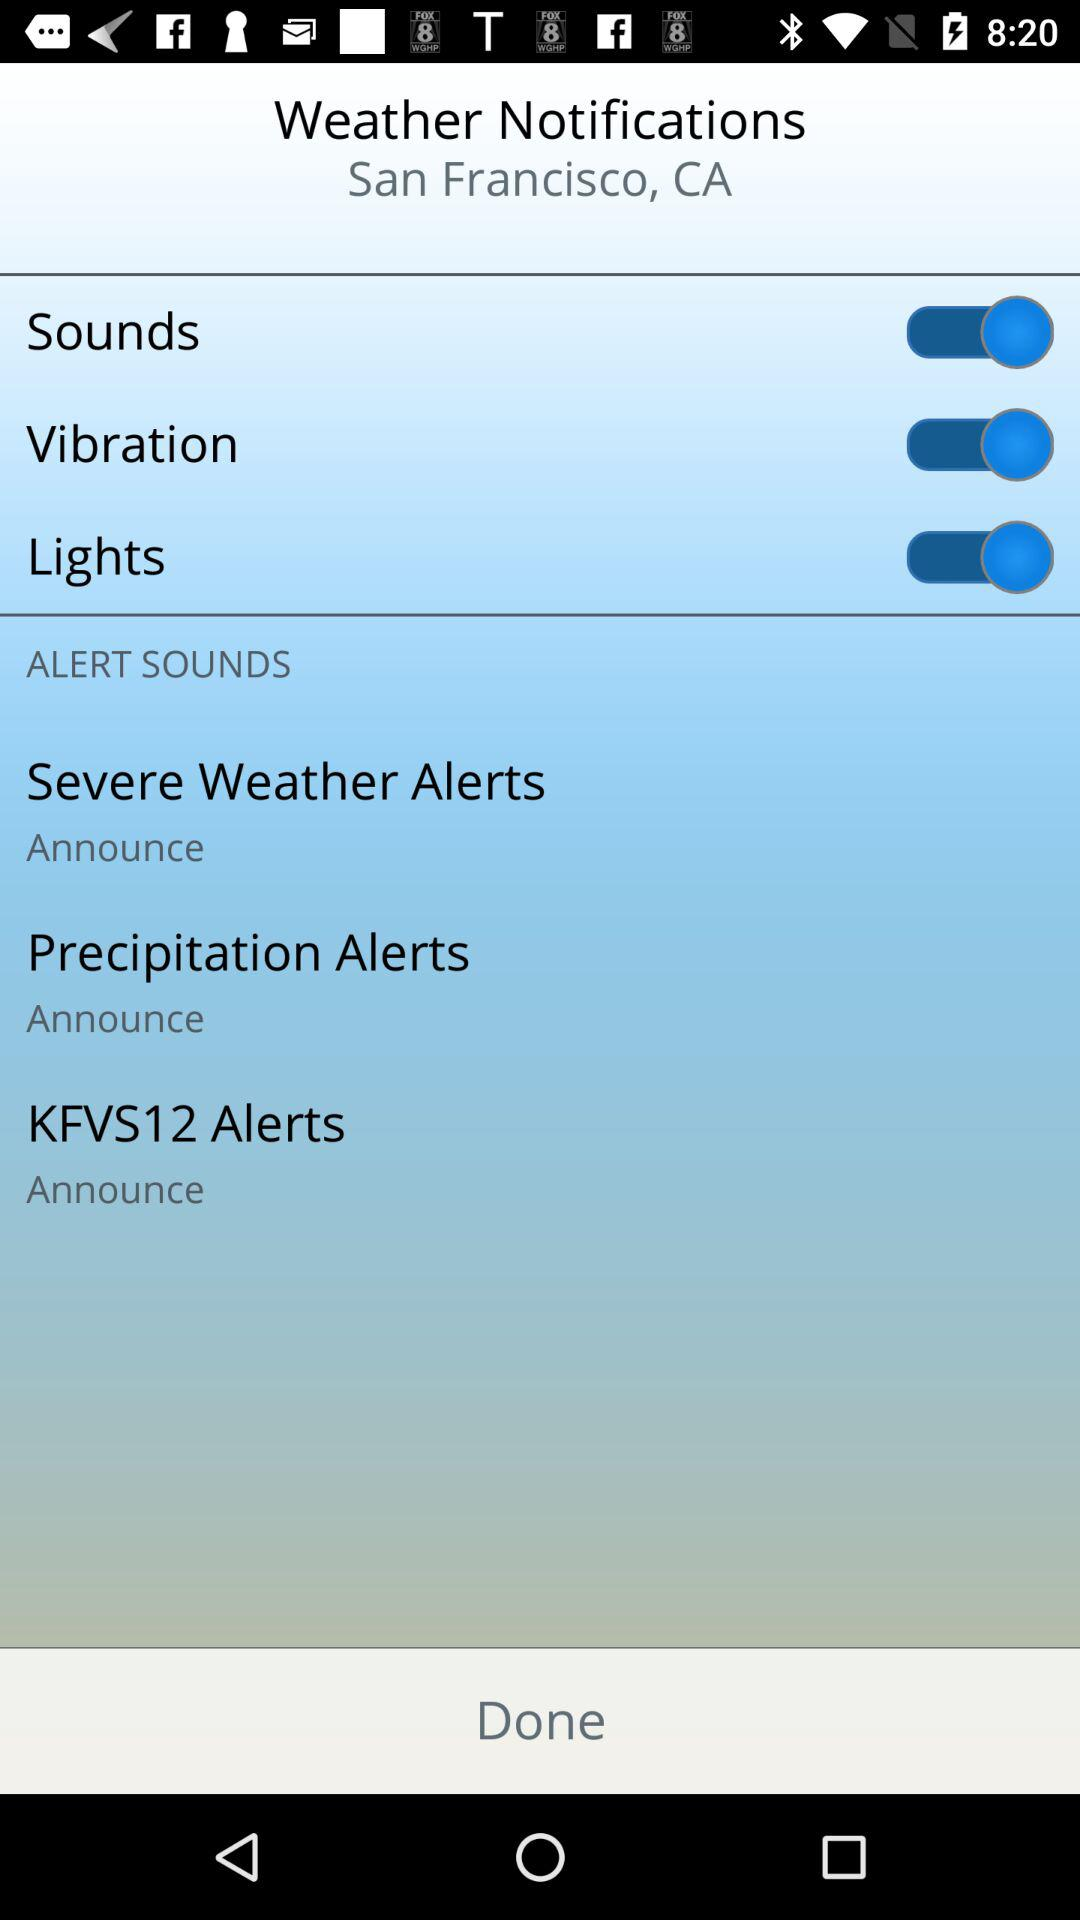How many alert types are there?
Answer the question using a single word or phrase. 3 